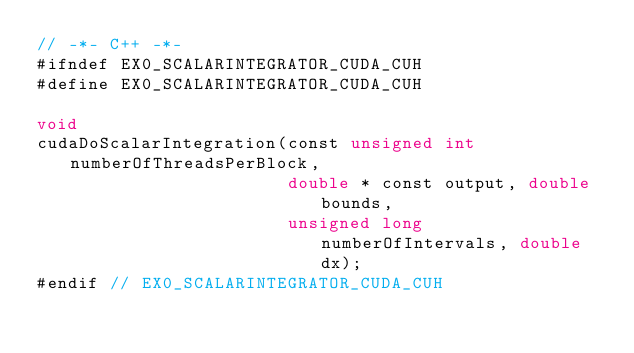<code> <loc_0><loc_0><loc_500><loc_500><_Cuda_>// -*- C++ -*-
#ifndef EX0_SCALARINTEGRATOR_CUDA_CUH
#define EX0_SCALARINTEGRATOR_CUDA_CUH

void
cudaDoScalarIntegration(const unsigned int numberOfThreadsPerBlock,
                        double * const output, double bounds, 
                        unsigned long numberOfIntervals, double dx);
#endif // EX0_SCALARINTEGRATOR_CUDA_CUH
</code> 